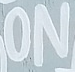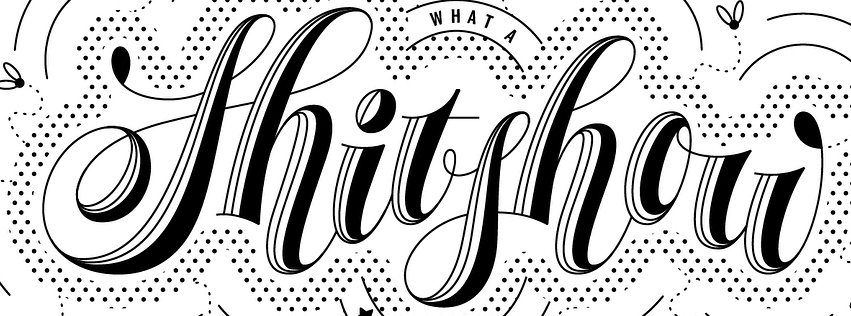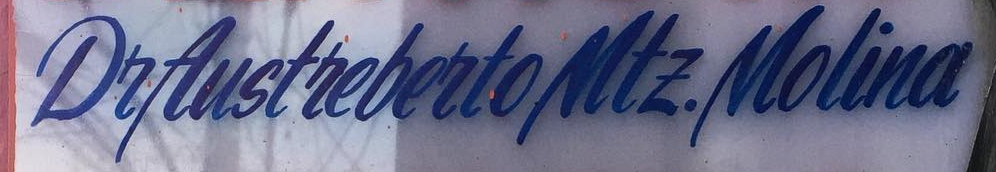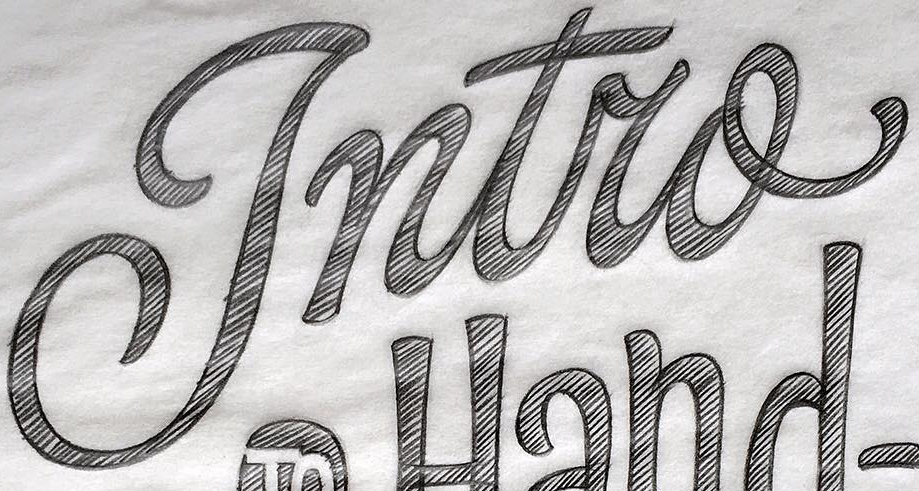What text appears in these images from left to right, separated by a semicolon? ON; Shitshou; DeAustrebertoMtE.Molina; Intro 